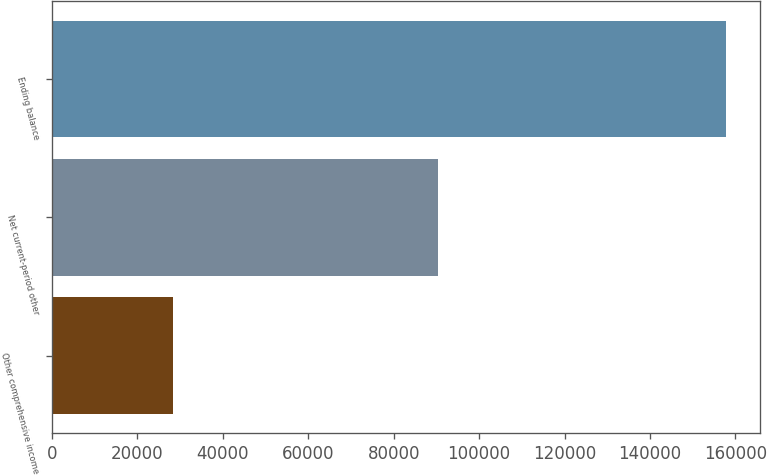Convert chart. <chart><loc_0><loc_0><loc_500><loc_500><bar_chart><fcel>Other comprehensive income<fcel>Net current-period other<fcel>Ending balance<nl><fcel>28437<fcel>90421<fcel>157864<nl></chart> 